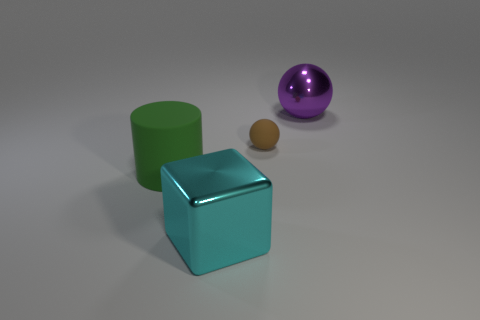Are there any other things that have the same shape as the large green rubber thing?
Your response must be concise. No. How many blocks are either cyan objects or brown matte objects?
Provide a short and direct response. 1. What is the color of the shiny thing in front of the purple metallic object?
Offer a very short reply. Cyan. What is the shape of the green thing that is the same size as the metal ball?
Your response must be concise. Cylinder. There is a purple thing; what number of cyan metal blocks are behind it?
Keep it short and to the point. 0. What number of objects are either big yellow matte objects or metallic objects?
Ensure brevity in your answer.  2. What is the shape of the large thing that is behind the large cyan shiny object and in front of the large purple thing?
Your answer should be very brief. Cylinder. How many purple spheres are there?
Make the answer very short. 1. There is a sphere that is made of the same material as the large green cylinder; what color is it?
Ensure brevity in your answer.  Brown. Is the number of tiny cubes greater than the number of large shiny objects?
Ensure brevity in your answer.  No. 